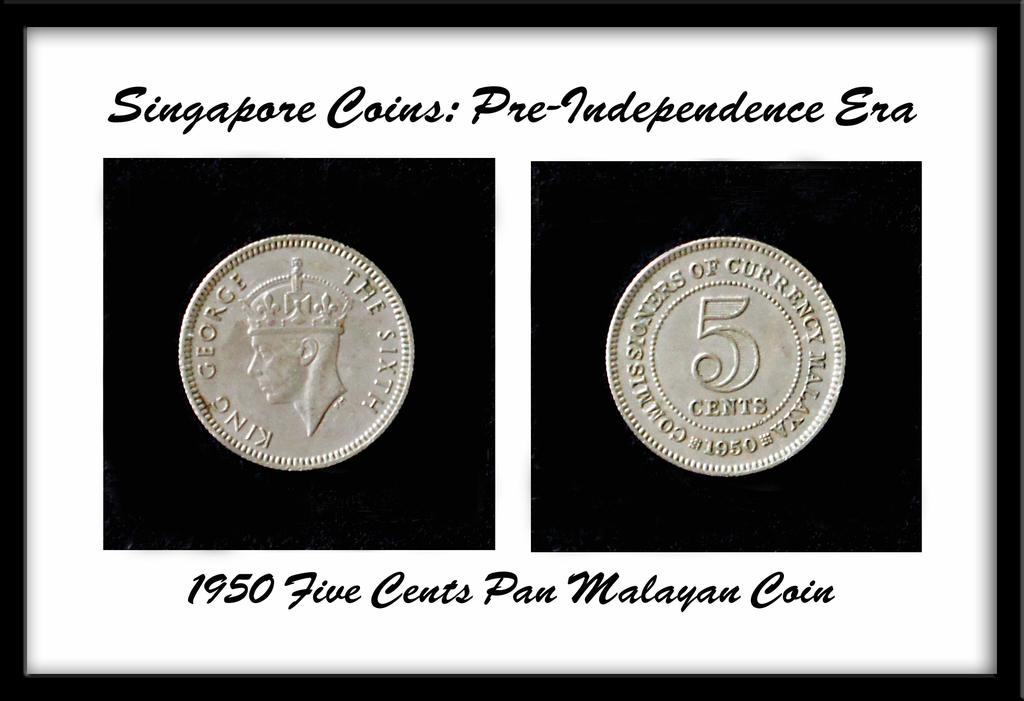What year are these coins?
Provide a succinct answer. 1950. Where are these coins from?
Your answer should be compact. Singapore. 